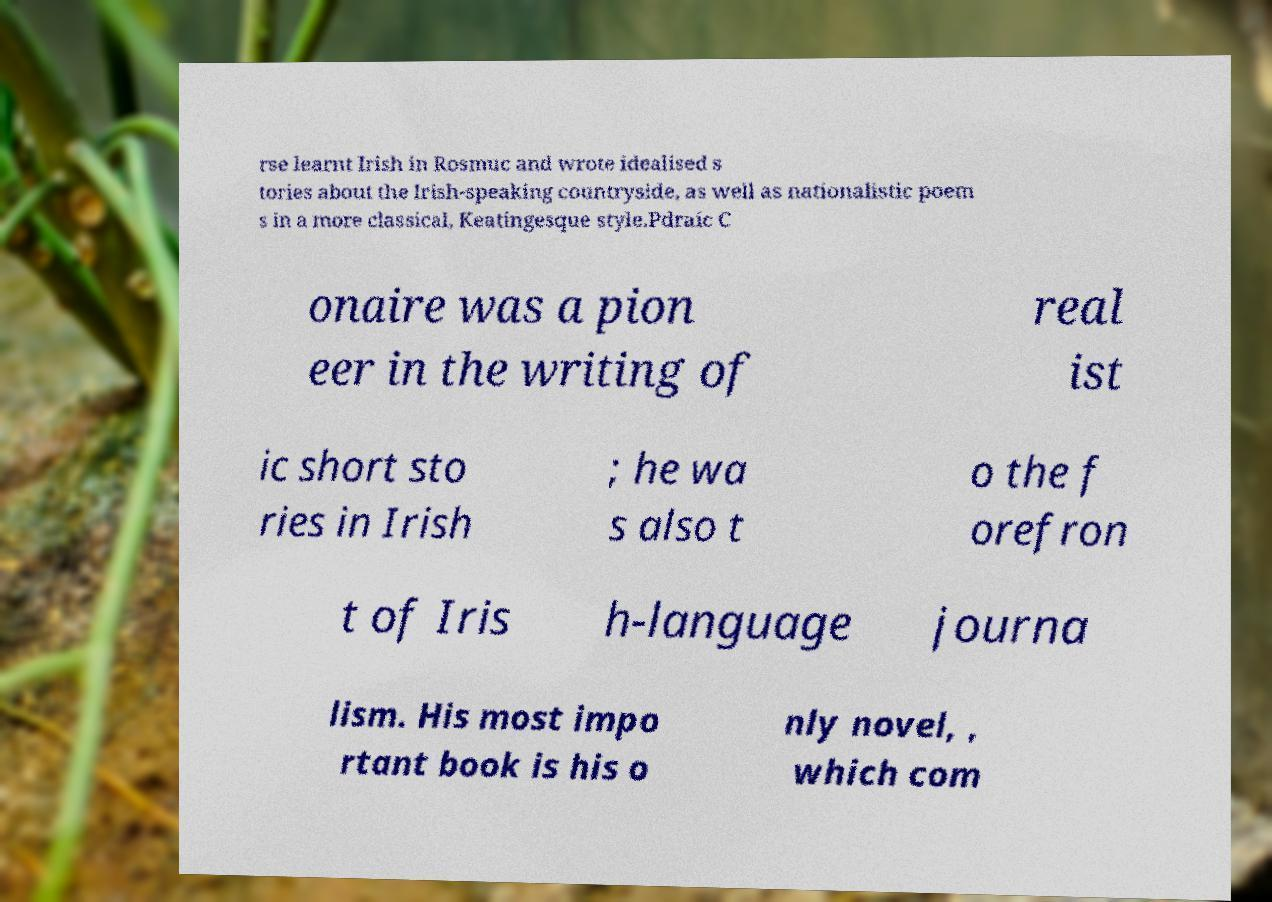Could you extract and type out the text from this image? rse learnt Irish in Rosmuc and wrote idealised s tories about the Irish-speaking countryside, as well as nationalistic poem s in a more classical, Keatingesque style.Pdraic C onaire was a pion eer in the writing of real ist ic short sto ries in Irish ; he wa s also t o the f orefron t of Iris h-language journa lism. His most impo rtant book is his o nly novel, , which com 